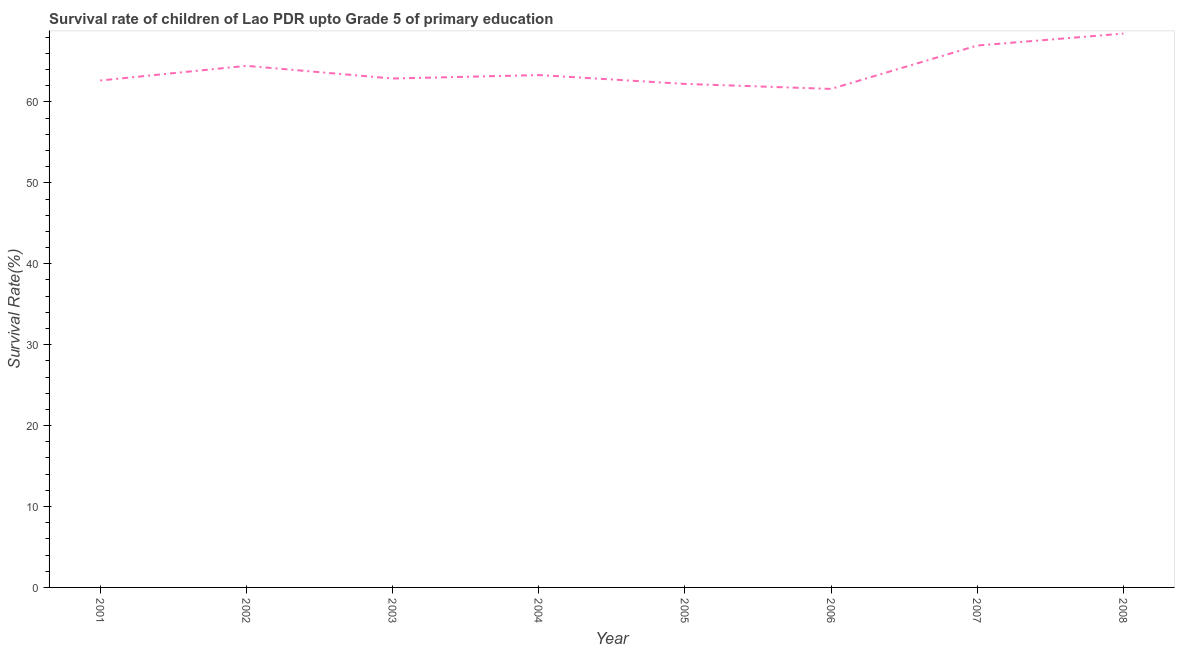What is the survival rate in 2004?
Your answer should be compact. 63.33. Across all years, what is the maximum survival rate?
Offer a terse response. 68.45. Across all years, what is the minimum survival rate?
Ensure brevity in your answer.  61.61. What is the sum of the survival rate?
Your response must be concise. 512.62. What is the difference between the survival rate in 2002 and 2006?
Make the answer very short. 2.86. What is the average survival rate per year?
Offer a terse response. 64.08. What is the median survival rate?
Your answer should be compact. 63.11. In how many years, is the survival rate greater than 60 %?
Provide a short and direct response. 8. Do a majority of the years between 2006 and 2005 (inclusive) have survival rate greater than 36 %?
Your answer should be very brief. No. What is the ratio of the survival rate in 2002 to that in 2007?
Offer a very short reply. 0.96. What is the difference between the highest and the second highest survival rate?
Your answer should be very brief. 1.48. What is the difference between the highest and the lowest survival rate?
Ensure brevity in your answer.  6.84. Does the survival rate monotonically increase over the years?
Give a very brief answer. No. How many lines are there?
Give a very brief answer. 1. What is the difference between two consecutive major ticks on the Y-axis?
Offer a terse response. 10. Are the values on the major ticks of Y-axis written in scientific E-notation?
Offer a terse response. No. What is the title of the graph?
Keep it short and to the point. Survival rate of children of Lao PDR upto Grade 5 of primary education. What is the label or title of the Y-axis?
Make the answer very short. Survival Rate(%). What is the Survival Rate(%) in 2001?
Provide a short and direct response. 62.66. What is the Survival Rate(%) of 2002?
Your response must be concise. 64.47. What is the Survival Rate(%) in 2003?
Your answer should be compact. 62.9. What is the Survival Rate(%) of 2004?
Offer a very short reply. 63.33. What is the Survival Rate(%) in 2005?
Your answer should be compact. 62.23. What is the Survival Rate(%) of 2006?
Your response must be concise. 61.61. What is the Survival Rate(%) in 2007?
Make the answer very short. 66.98. What is the Survival Rate(%) of 2008?
Offer a very short reply. 68.45. What is the difference between the Survival Rate(%) in 2001 and 2002?
Give a very brief answer. -1.81. What is the difference between the Survival Rate(%) in 2001 and 2003?
Keep it short and to the point. -0.24. What is the difference between the Survival Rate(%) in 2001 and 2004?
Make the answer very short. -0.67. What is the difference between the Survival Rate(%) in 2001 and 2005?
Ensure brevity in your answer.  0.42. What is the difference between the Survival Rate(%) in 2001 and 2006?
Make the answer very short. 1.04. What is the difference between the Survival Rate(%) in 2001 and 2007?
Your answer should be very brief. -4.32. What is the difference between the Survival Rate(%) in 2001 and 2008?
Offer a terse response. -5.8. What is the difference between the Survival Rate(%) in 2002 and 2003?
Give a very brief answer. 1.57. What is the difference between the Survival Rate(%) in 2002 and 2004?
Your answer should be very brief. 1.14. What is the difference between the Survival Rate(%) in 2002 and 2005?
Your answer should be compact. 2.23. What is the difference between the Survival Rate(%) in 2002 and 2006?
Keep it short and to the point. 2.86. What is the difference between the Survival Rate(%) in 2002 and 2007?
Make the answer very short. -2.51. What is the difference between the Survival Rate(%) in 2002 and 2008?
Your response must be concise. -3.98. What is the difference between the Survival Rate(%) in 2003 and 2004?
Offer a terse response. -0.43. What is the difference between the Survival Rate(%) in 2003 and 2005?
Ensure brevity in your answer.  0.67. What is the difference between the Survival Rate(%) in 2003 and 2006?
Your answer should be very brief. 1.29. What is the difference between the Survival Rate(%) in 2003 and 2007?
Make the answer very short. -4.08. What is the difference between the Survival Rate(%) in 2003 and 2008?
Provide a succinct answer. -5.55. What is the difference between the Survival Rate(%) in 2004 and 2005?
Give a very brief answer. 1.09. What is the difference between the Survival Rate(%) in 2004 and 2006?
Your answer should be compact. 1.71. What is the difference between the Survival Rate(%) in 2004 and 2007?
Your answer should be very brief. -3.65. What is the difference between the Survival Rate(%) in 2004 and 2008?
Offer a very short reply. -5.13. What is the difference between the Survival Rate(%) in 2005 and 2006?
Your response must be concise. 0.62. What is the difference between the Survival Rate(%) in 2005 and 2007?
Provide a short and direct response. -4.74. What is the difference between the Survival Rate(%) in 2005 and 2008?
Provide a short and direct response. -6.22. What is the difference between the Survival Rate(%) in 2006 and 2007?
Ensure brevity in your answer.  -5.36. What is the difference between the Survival Rate(%) in 2006 and 2008?
Keep it short and to the point. -6.84. What is the difference between the Survival Rate(%) in 2007 and 2008?
Offer a very short reply. -1.48. What is the ratio of the Survival Rate(%) in 2001 to that in 2002?
Keep it short and to the point. 0.97. What is the ratio of the Survival Rate(%) in 2001 to that in 2004?
Give a very brief answer. 0.99. What is the ratio of the Survival Rate(%) in 2001 to that in 2006?
Your answer should be compact. 1.02. What is the ratio of the Survival Rate(%) in 2001 to that in 2007?
Offer a very short reply. 0.94. What is the ratio of the Survival Rate(%) in 2001 to that in 2008?
Your answer should be very brief. 0.92. What is the ratio of the Survival Rate(%) in 2002 to that in 2005?
Your response must be concise. 1.04. What is the ratio of the Survival Rate(%) in 2002 to that in 2006?
Give a very brief answer. 1.05. What is the ratio of the Survival Rate(%) in 2002 to that in 2007?
Offer a very short reply. 0.96. What is the ratio of the Survival Rate(%) in 2002 to that in 2008?
Provide a short and direct response. 0.94. What is the ratio of the Survival Rate(%) in 2003 to that in 2006?
Your answer should be compact. 1.02. What is the ratio of the Survival Rate(%) in 2003 to that in 2007?
Provide a succinct answer. 0.94. What is the ratio of the Survival Rate(%) in 2003 to that in 2008?
Your answer should be compact. 0.92. What is the ratio of the Survival Rate(%) in 2004 to that in 2006?
Your response must be concise. 1.03. What is the ratio of the Survival Rate(%) in 2004 to that in 2007?
Keep it short and to the point. 0.95. What is the ratio of the Survival Rate(%) in 2004 to that in 2008?
Your answer should be very brief. 0.93. What is the ratio of the Survival Rate(%) in 2005 to that in 2006?
Ensure brevity in your answer.  1.01. What is the ratio of the Survival Rate(%) in 2005 to that in 2007?
Provide a succinct answer. 0.93. What is the ratio of the Survival Rate(%) in 2005 to that in 2008?
Provide a succinct answer. 0.91. What is the ratio of the Survival Rate(%) in 2007 to that in 2008?
Your response must be concise. 0.98. 